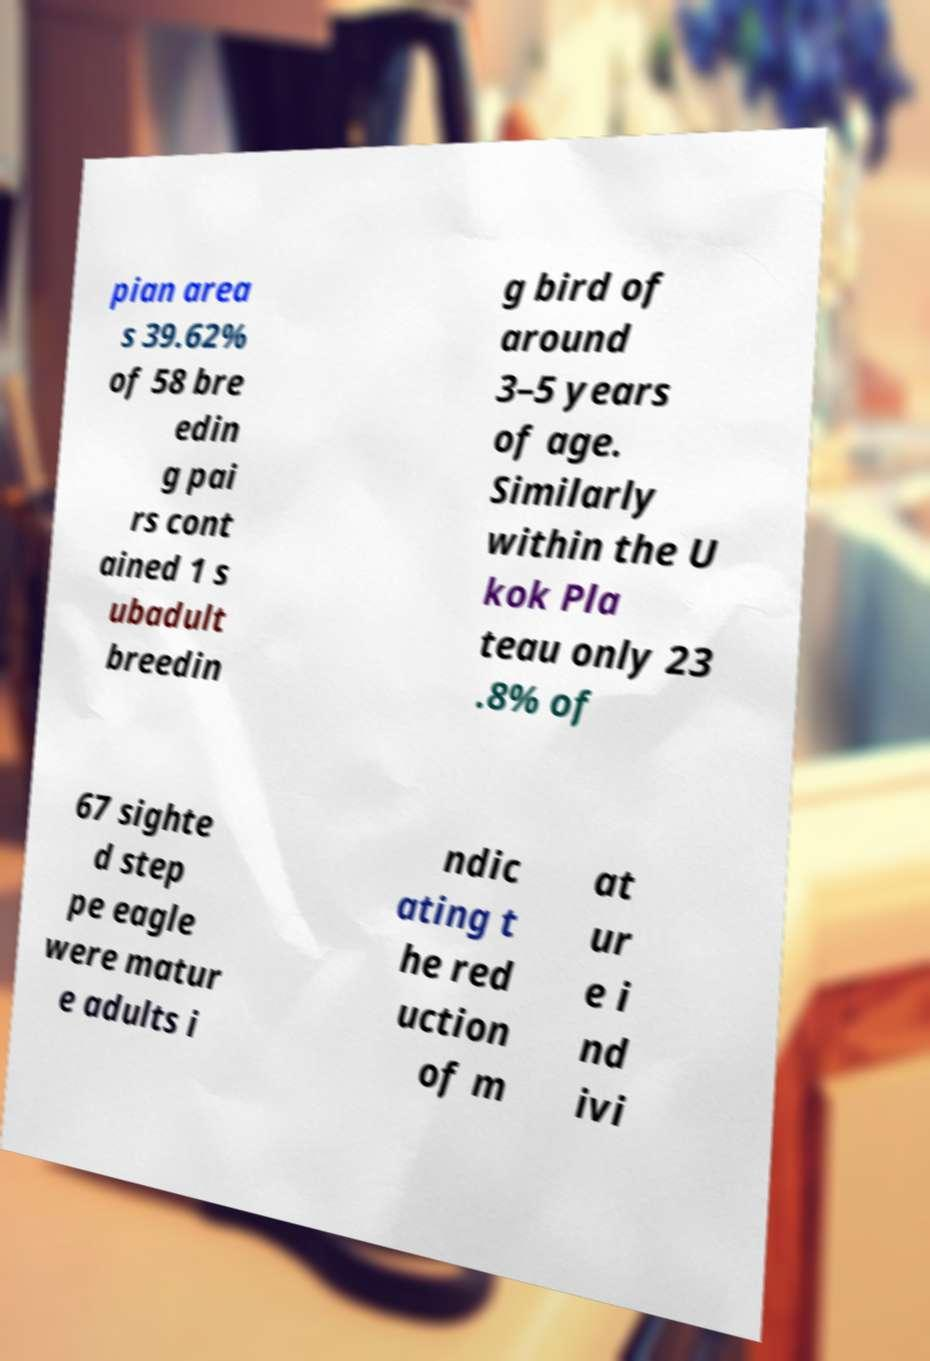There's text embedded in this image that I need extracted. Can you transcribe it verbatim? pian area s 39.62% of 58 bre edin g pai rs cont ained 1 s ubadult breedin g bird of around 3–5 years of age. Similarly within the U kok Pla teau only 23 .8% of 67 sighte d step pe eagle were matur e adults i ndic ating t he red uction of m at ur e i nd ivi 